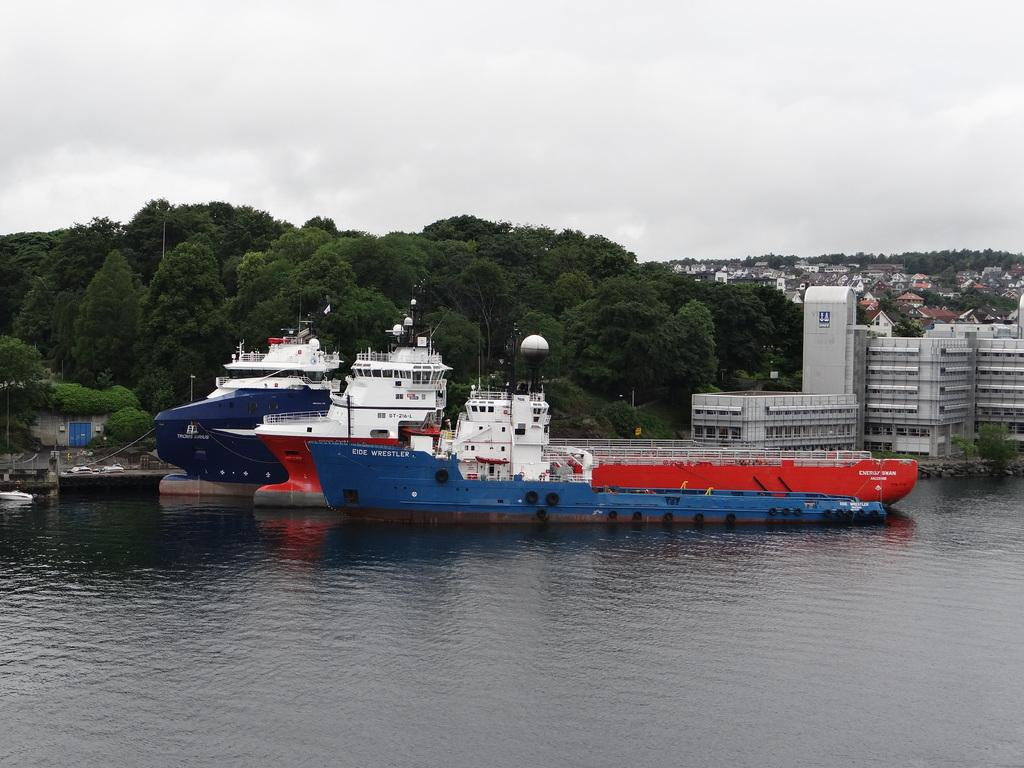What type of natural feature can be seen in the image? There is a water body in the image. What is on the water body? Ships are present on the water body. What can be seen in the distance in the image? There are buildings and trees visible in the background of the image. How would you describe the weather in the image? The sky is cloudy in the image. What type of vegetable is being served for lunch in the image? There is no indication of a vegetable or lunch being served in the image; it primarily features a water body with ships and a cloudy sky. 